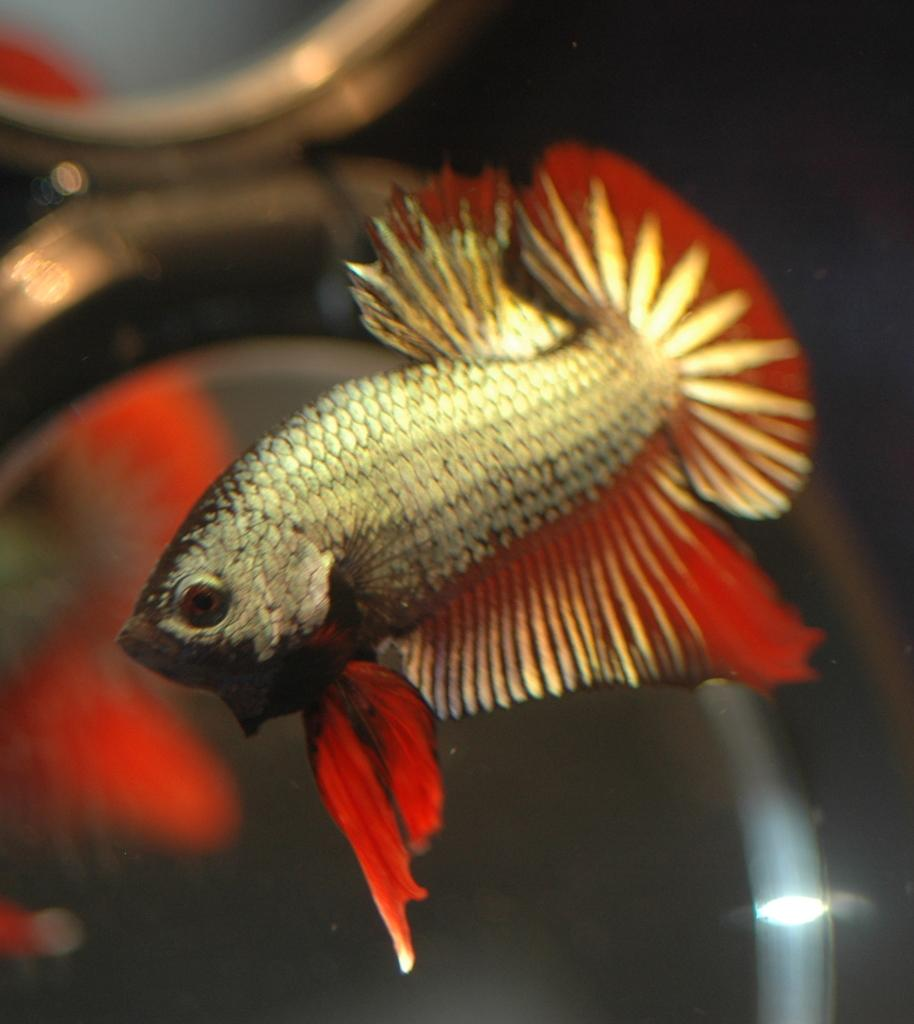What type of animal is in the image? There is a fish in the image. Where is the fish located? The fish is in the water. What type of produce is being discussed by the spiders in the image? There are no spiders or discussion of produce present in the image; it features a fish in the water. 